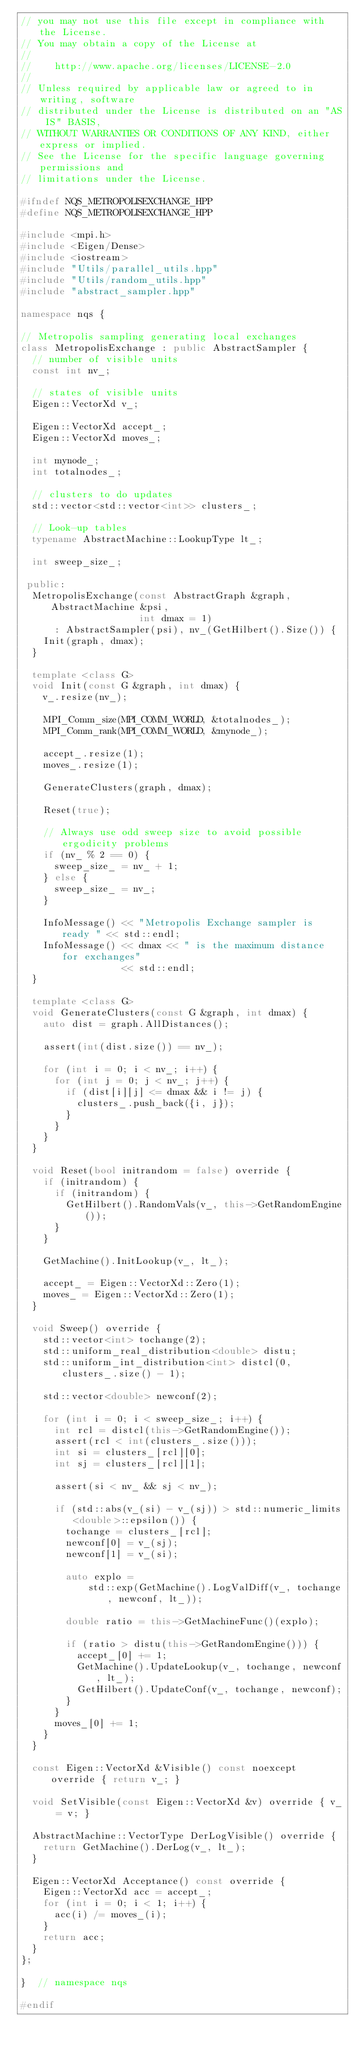<code> <loc_0><loc_0><loc_500><loc_500><_C++_>// you may not use this file except in compliance with the License.
// You may obtain a copy of the License at
//
//    http://www.apache.org/licenses/LICENSE-2.0
//
// Unless required by applicable law or agreed to in writing, software
// distributed under the License is distributed on an "AS IS" BASIS,
// WITHOUT WARRANTIES OR CONDITIONS OF ANY KIND, either express or implied.
// See the License for the specific language governing permissions and
// limitations under the License.

#ifndef NQS_METROPOLISEXCHANGE_HPP
#define NQS_METROPOLISEXCHANGE_HPP

#include <mpi.h>
#include <Eigen/Dense>
#include <iostream>
#include "Utils/parallel_utils.hpp"
#include "Utils/random_utils.hpp"
#include "abstract_sampler.hpp"

namespace nqs {

// Metropolis sampling generating local exchanges
class MetropolisExchange : public AbstractSampler {
  // number of visible units
  const int nv_;

  // states of visible units
  Eigen::VectorXd v_;

  Eigen::VectorXd accept_;
  Eigen::VectorXd moves_;

  int mynode_;
  int totalnodes_;

  // clusters to do updates
  std::vector<std::vector<int>> clusters_;

  // Look-up tables
  typename AbstractMachine::LookupType lt_;

  int sweep_size_;

 public:
  MetropolisExchange(const AbstractGraph &graph, AbstractMachine &psi,
                     int dmax = 1)
      : AbstractSampler(psi), nv_(GetHilbert().Size()) {
    Init(graph, dmax);
  }

  template <class G>
  void Init(const G &graph, int dmax) {
    v_.resize(nv_);

    MPI_Comm_size(MPI_COMM_WORLD, &totalnodes_);
    MPI_Comm_rank(MPI_COMM_WORLD, &mynode_);

    accept_.resize(1);
    moves_.resize(1);

    GenerateClusters(graph, dmax);

    Reset(true);

    // Always use odd sweep size to avoid possible ergodicity problems
    if (nv_ % 2 == 0) {
      sweep_size_ = nv_ + 1;
    } else {
      sweep_size_ = nv_;
    }

    InfoMessage() << "Metropolis Exchange sampler is ready " << std::endl;
    InfoMessage() << dmax << " is the maximum distance for exchanges"
                  << std::endl;
  }

  template <class G>
  void GenerateClusters(const G &graph, int dmax) {
    auto dist = graph.AllDistances();

    assert(int(dist.size()) == nv_);

    for (int i = 0; i < nv_; i++) {
      for (int j = 0; j < nv_; j++) {
        if (dist[i][j] <= dmax && i != j) {
          clusters_.push_back({i, j});
        }
      }
    }
  }

  void Reset(bool initrandom = false) override {
    if (initrandom) {
      if (initrandom) {
        GetHilbert().RandomVals(v_, this->GetRandomEngine());
      }
    }

    GetMachine().InitLookup(v_, lt_);

    accept_ = Eigen::VectorXd::Zero(1);
    moves_ = Eigen::VectorXd::Zero(1);
  }

  void Sweep() override {
    std::vector<int> tochange(2);
    std::uniform_real_distribution<double> distu;
    std::uniform_int_distribution<int> distcl(0, clusters_.size() - 1);

    std::vector<double> newconf(2);

    for (int i = 0; i < sweep_size_; i++) {
      int rcl = distcl(this->GetRandomEngine());
      assert(rcl < int(clusters_.size()));
      int si = clusters_[rcl][0];
      int sj = clusters_[rcl][1];

      assert(si < nv_ && sj < nv_);

      if (std::abs(v_(si) - v_(sj)) > std::numeric_limits<double>::epsilon()) {
        tochange = clusters_[rcl];
        newconf[0] = v_(sj);
        newconf[1] = v_(si);

        auto explo =
            std::exp(GetMachine().LogValDiff(v_, tochange, newconf, lt_));

        double ratio = this->GetMachineFunc()(explo);

        if (ratio > distu(this->GetRandomEngine())) {
          accept_[0] += 1;
          GetMachine().UpdateLookup(v_, tochange, newconf, lt_);
          GetHilbert().UpdateConf(v_, tochange, newconf);
        }
      }
      moves_[0] += 1;
    }
  }

  const Eigen::VectorXd &Visible() const noexcept override { return v_; }

  void SetVisible(const Eigen::VectorXd &v) override { v_ = v; }

  AbstractMachine::VectorType DerLogVisible() override {
    return GetMachine().DerLog(v_, lt_);
  }

  Eigen::VectorXd Acceptance() const override {
    Eigen::VectorXd acc = accept_;
    for (int i = 0; i < 1; i++) {
      acc(i) /= moves_(i);
    }
    return acc;
  }
};

}  // namespace nqs

#endif
</code> 